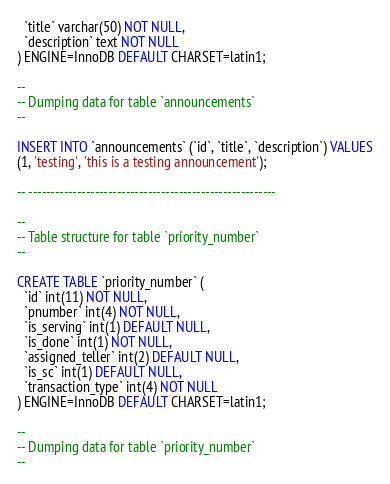Convert code to text. <code><loc_0><loc_0><loc_500><loc_500><_SQL_>  `title` varchar(50) NOT NULL,
  `description` text NOT NULL
) ENGINE=InnoDB DEFAULT CHARSET=latin1;

--
-- Dumping data for table `announcements`
--

INSERT INTO `announcements` (`id`, `title`, `description`) VALUES
(1, 'testing', 'this is a testing announcement');

-- --------------------------------------------------------

--
-- Table structure for table `priority_number`
--

CREATE TABLE `priority_number` (
  `id` int(11) NOT NULL,
  `pnumber` int(4) NOT NULL,
  `is_serving` int(1) DEFAULT NULL,
  `is_done` int(1) NOT NULL,
  `assigned_teller` int(2) DEFAULT NULL,
  `is_sc` int(1) DEFAULT NULL,
  `transaction_type` int(4) NOT NULL
) ENGINE=InnoDB DEFAULT CHARSET=latin1;

--
-- Dumping data for table `priority_number`
--
</code> 